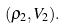<formula> <loc_0><loc_0><loc_500><loc_500>( \rho _ { 2 } , V _ { 2 } ) .</formula> 